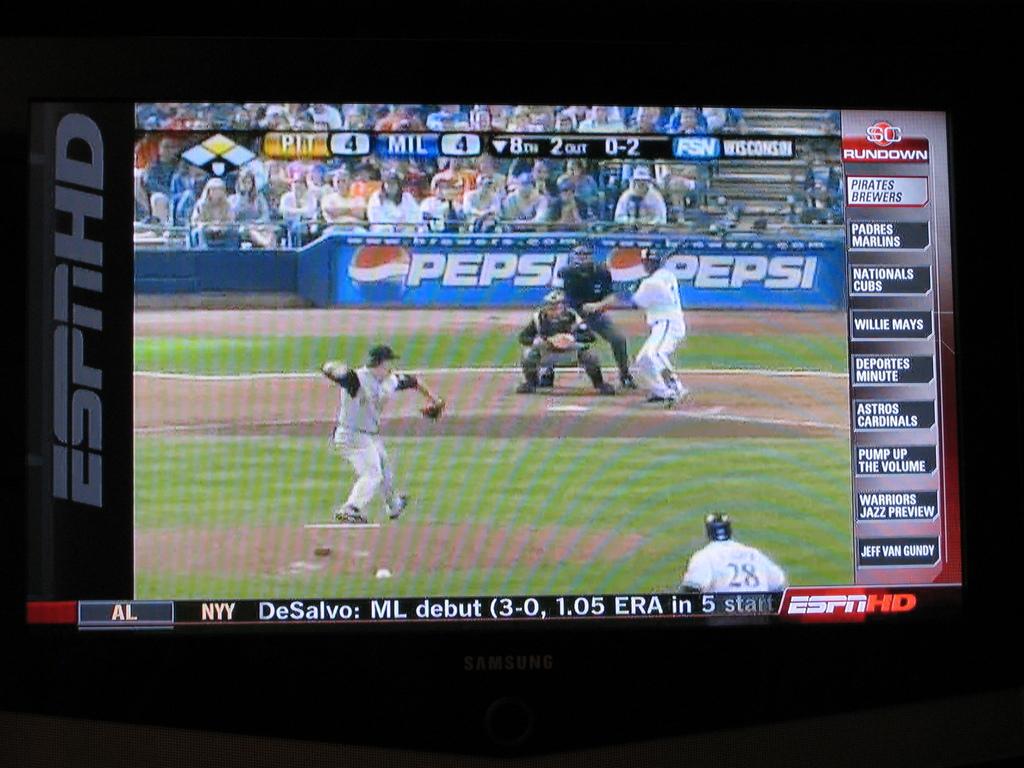Who is playing in the game?
Make the answer very short. Pit and mil. What channel is the game one?
Give a very brief answer. Espn. 